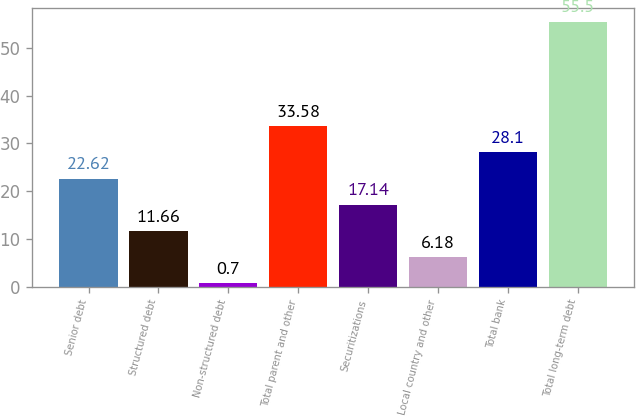<chart> <loc_0><loc_0><loc_500><loc_500><bar_chart><fcel>Senior debt<fcel>Structured debt<fcel>Non-structured debt<fcel>Total parent and other<fcel>Securitizations<fcel>Local country and other<fcel>Total bank<fcel>Total long-term debt<nl><fcel>22.62<fcel>11.66<fcel>0.7<fcel>33.58<fcel>17.14<fcel>6.18<fcel>28.1<fcel>55.5<nl></chart> 